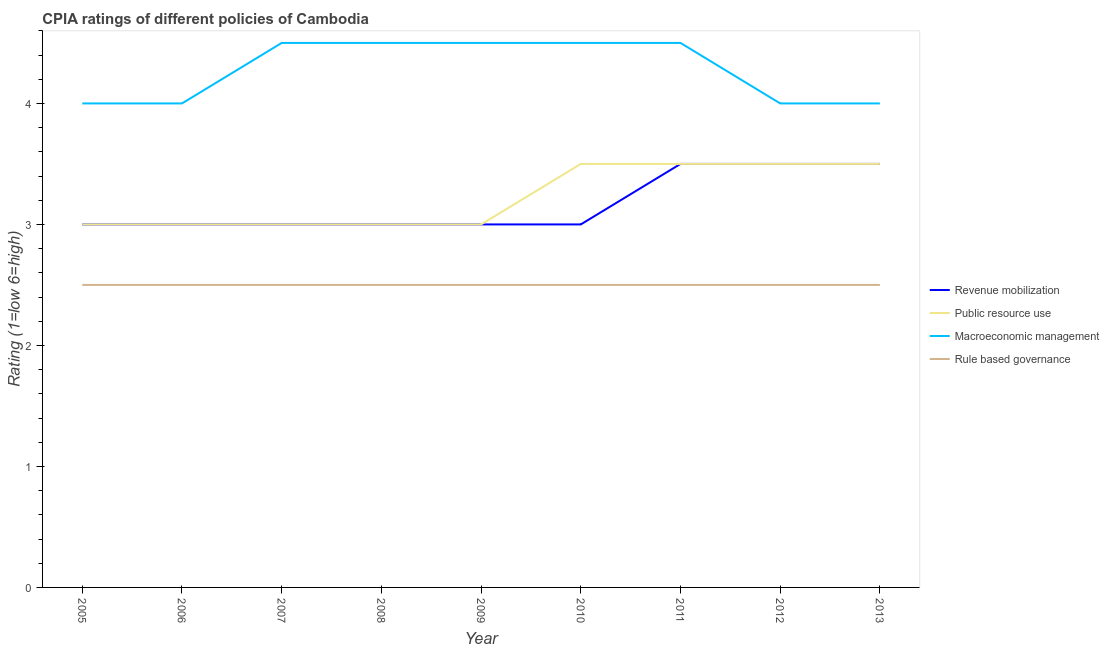How many different coloured lines are there?
Provide a short and direct response. 4. Does the line corresponding to cpia rating of public resource use intersect with the line corresponding to cpia rating of macroeconomic management?
Your response must be concise. No. Is the number of lines equal to the number of legend labels?
Your response must be concise. Yes. What is the cpia rating of public resource use in 2010?
Offer a very short reply. 3.5. Across all years, what is the maximum cpia rating of public resource use?
Keep it short and to the point. 3.5. Across all years, what is the minimum cpia rating of rule based governance?
Keep it short and to the point. 2.5. In which year was the cpia rating of revenue mobilization maximum?
Provide a short and direct response. 2011. In which year was the cpia rating of revenue mobilization minimum?
Your answer should be compact. 2005. What is the total cpia rating of rule based governance in the graph?
Your answer should be compact. 22.5. What is the average cpia rating of macroeconomic management per year?
Your response must be concise. 4.28. In how many years, is the cpia rating of revenue mobilization greater than 4.4?
Ensure brevity in your answer.  0. Is the difference between the cpia rating of public resource use in 2005 and 2008 greater than the difference between the cpia rating of macroeconomic management in 2005 and 2008?
Make the answer very short. Yes. What is the difference between the highest and the lowest cpia rating of revenue mobilization?
Your response must be concise. 0.5. Is it the case that in every year, the sum of the cpia rating of revenue mobilization and cpia rating of public resource use is greater than the sum of cpia rating of macroeconomic management and cpia rating of rule based governance?
Make the answer very short. No. Is it the case that in every year, the sum of the cpia rating of revenue mobilization and cpia rating of public resource use is greater than the cpia rating of macroeconomic management?
Your answer should be compact. Yes. Does the cpia rating of rule based governance monotonically increase over the years?
Your answer should be very brief. No. Is the cpia rating of public resource use strictly greater than the cpia rating of revenue mobilization over the years?
Ensure brevity in your answer.  No. Is the cpia rating of public resource use strictly less than the cpia rating of macroeconomic management over the years?
Provide a succinct answer. Yes. How many lines are there?
Your answer should be compact. 4. How many years are there in the graph?
Your answer should be very brief. 9. What is the difference between two consecutive major ticks on the Y-axis?
Offer a very short reply. 1. Are the values on the major ticks of Y-axis written in scientific E-notation?
Make the answer very short. No. Does the graph contain any zero values?
Keep it short and to the point. No. Where does the legend appear in the graph?
Your response must be concise. Center right. What is the title of the graph?
Offer a terse response. CPIA ratings of different policies of Cambodia. What is the label or title of the X-axis?
Offer a very short reply. Year. What is the label or title of the Y-axis?
Your answer should be very brief. Rating (1=low 6=high). What is the Rating (1=low 6=high) in Revenue mobilization in 2005?
Provide a succinct answer. 3. What is the Rating (1=low 6=high) of Public resource use in 2005?
Your answer should be very brief. 3. What is the Rating (1=low 6=high) in Macroeconomic management in 2005?
Give a very brief answer. 4. What is the Rating (1=low 6=high) in Revenue mobilization in 2006?
Offer a very short reply. 3. What is the Rating (1=low 6=high) in Macroeconomic management in 2006?
Keep it short and to the point. 4. What is the Rating (1=low 6=high) of Public resource use in 2007?
Your answer should be very brief. 3. What is the Rating (1=low 6=high) in Macroeconomic management in 2007?
Offer a very short reply. 4.5. What is the Rating (1=low 6=high) in Rule based governance in 2008?
Ensure brevity in your answer.  2.5. What is the Rating (1=low 6=high) of Public resource use in 2010?
Your answer should be compact. 3.5. What is the Rating (1=low 6=high) in Macroeconomic management in 2010?
Keep it short and to the point. 4.5. What is the Rating (1=low 6=high) of Rule based governance in 2010?
Ensure brevity in your answer.  2.5. What is the Rating (1=low 6=high) in Revenue mobilization in 2011?
Provide a succinct answer. 3.5. What is the Rating (1=low 6=high) in Rule based governance in 2011?
Keep it short and to the point. 2.5. What is the Rating (1=low 6=high) in Revenue mobilization in 2012?
Your answer should be compact. 3.5. What is the Rating (1=low 6=high) in Macroeconomic management in 2012?
Offer a terse response. 4. What is the Rating (1=low 6=high) of Rule based governance in 2012?
Offer a terse response. 2.5. What is the Rating (1=low 6=high) in Public resource use in 2013?
Offer a very short reply. 3.5. What is the Rating (1=low 6=high) of Macroeconomic management in 2013?
Your response must be concise. 4. Across all years, what is the maximum Rating (1=low 6=high) in Revenue mobilization?
Ensure brevity in your answer.  3.5. Across all years, what is the maximum Rating (1=low 6=high) in Macroeconomic management?
Offer a terse response. 4.5. Across all years, what is the maximum Rating (1=low 6=high) of Rule based governance?
Keep it short and to the point. 2.5. Across all years, what is the minimum Rating (1=low 6=high) in Revenue mobilization?
Keep it short and to the point. 3. Across all years, what is the minimum Rating (1=low 6=high) of Rule based governance?
Provide a short and direct response. 2.5. What is the total Rating (1=low 6=high) in Public resource use in the graph?
Offer a very short reply. 29. What is the total Rating (1=low 6=high) of Macroeconomic management in the graph?
Keep it short and to the point. 38.5. What is the total Rating (1=low 6=high) of Rule based governance in the graph?
Provide a short and direct response. 22.5. What is the difference between the Rating (1=low 6=high) in Public resource use in 2005 and that in 2006?
Make the answer very short. 0. What is the difference between the Rating (1=low 6=high) in Rule based governance in 2005 and that in 2006?
Make the answer very short. 0. What is the difference between the Rating (1=low 6=high) of Macroeconomic management in 2005 and that in 2007?
Your answer should be very brief. -0.5. What is the difference between the Rating (1=low 6=high) in Public resource use in 2005 and that in 2008?
Provide a succinct answer. 0. What is the difference between the Rating (1=low 6=high) of Rule based governance in 2005 and that in 2008?
Your response must be concise. 0. What is the difference between the Rating (1=low 6=high) of Revenue mobilization in 2005 and that in 2009?
Ensure brevity in your answer.  0. What is the difference between the Rating (1=low 6=high) of Public resource use in 2005 and that in 2009?
Make the answer very short. 0. What is the difference between the Rating (1=low 6=high) of Macroeconomic management in 2005 and that in 2009?
Ensure brevity in your answer.  -0.5. What is the difference between the Rating (1=low 6=high) in Revenue mobilization in 2005 and that in 2010?
Your answer should be compact. 0. What is the difference between the Rating (1=low 6=high) of Public resource use in 2005 and that in 2010?
Your answer should be very brief. -0.5. What is the difference between the Rating (1=low 6=high) of Revenue mobilization in 2005 and that in 2011?
Provide a succinct answer. -0.5. What is the difference between the Rating (1=low 6=high) of Macroeconomic management in 2005 and that in 2011?
Make the answer very short. -0.5. What is the difference between the Rating (1=low 6=high) of Revenue mobilization in 2005 and that in 2012?
Provide a succinct answer. -0.5. What is the difference between the Rating (1=low 6=high) in Macroeconomic management in 2005 and that in 2012?
Your answer should be compact. 0. What is the difference between the Rating (1=low 6=high) in Rule based governance in 2005 and that in 2012?
Keep it short and to the point. 0. What is the difference between the Rating (1=low 6=high) in Rule based governance in 2005 and that in 2013?
Your answer should be compact. 0. What is the difference between the Rating (1=low 6=high) of Revenue mobilization in 2006 and that in 2007?
Offer a very short reply. 0. What is the difference between the Rating (1=low 6=high) of Rule based governance in 2006 and that in 2007?
Offer a terse response. 0. What is the difference between the Rating (1=low 6=high) in Public resource use in 2006 and that in 2008?
Give a very brief answer. 0. What is the difference between the Rating (1=low 6=high) of Revenue mobilization in 2006 and that in 2009?
Your answer should be very brief. 0. What is the difference between the Rating (1=low 6=high) in Public resource use in 2006 and that in 2009?
Give a very brief answer. 0. What is the difference between the Rating (1=low 6=high) of Macroeconomic management in 2006 and that in 2009?
Keep it short and to the point. -0.5. What is the difference between the Rating (1=low 6=high) in Rule based governance in 2006 and that in 2009?
Provide a succinct answer. 0. What is the difference between the Rating (1=low 6=high) in Revenue mobilization in 2006 and that in 2010?
Your response must be concise. 0. What is the difference between the Rating (1=low 6=high) in Public resource use in 2006 and that in 2010?
Your answer should be very brief. -0.5. What is the difference between the Rating (1=low 6=high) in Revenue mobilization in 2006 and that in 2011?
Provide a succinct answer. -0.5. What is the difference between the Rating (1=low 6=high) in Rule based governance in 2006 and that in 2011?
Ensure brevity in your answer.  0. What is the difference between the Rating (1=low 6=high) of Revenue mobilization in 2006 and that in 2012?
Offer a terse response. -0.5. What is the difference between the Rating (1=low 6=high) of Public resource use in 2006 and that in 2012?
Your answer should be compact. -0.5. What is the difference between the Rating (1=low 6=high) in Rule based governance in 2006 and that in 2012?
Provide a short and direct response. 0. What is the difference between the Rating (1=low 6=high) in Macroeconomic management in 2006 and that in 2013?
Your answer should be very brief. 0. What is the difference between the Rating (1=low 6=high) in Rule based governance in 2006 and that in 2013?
Give a very brief answer. 0. What is the difference between the Rating (1=low 6=high) of Public resource use in 2007 and that in 2008?
Offer a terse response. 0. What is the difference between the Rating (1=low 6=high) of Rule based governance in 2007 and that in 2008?
Give a very brief answer. 0. What is the difference between the Rating (1=low 6=high) in Public resource use in 2007 and that in 2009?
Your response must be concise. 0. What is the difference between the Rating (1=low 6=high) of Rule based governance in 2007 and that in 2009?
Keep it short and to the point. 0. What is the difference between the Rating (1=low 6=high) in Revenue mobilization in 2007 and that in 2010?
Provide a short and direct response. 0. What is the difference between the Rating (1=low 6=high) of Public resource use in 2007 and that in 2010?
Your answer should be compact. -0.5. What is the difference between the Rating (1=low 6=high) of Macroeconomic management in 2007 and that in 2010?
Offer a very short reply. 0. What is the difference between the Rating (1=low 6=high) in Public resource use in 2007 and that in 2011?
Ensure brevity in your answer.  -0.5. What is the difference between the Rating (1=low 6=high) of Macroeconomic management in 2007 and that in 2011?
Provide a succinct answer. 0. What is the difference between the Rating (1=low 6=high) in Rule based governance in 2007 and that in 2011?
Give a very brief answer. 0. What is the difference between the Rating (1=low 6=high) of Macroeconomic management in 2007 and that in 2012?
Your answer should be compact. 0.5. What is the difference between the Rating (1=low 6=high) in Rule based governance in 2007 and that in 2012?
Your response must be concise. 0. What is the difference between the Rating (1=low 6=high) in Revenue mobilization in 2008 and that in 2009?
Provide a succinct answer. 0. What is the difference between the Rating (1=low 6=high) in Public resource use in 2008 and that in 2009?
Offer a terse response. 0. What is the difference between the Rating (1=low 6=high) in Rule based governance in 2008 and that in 2009?
Your response must be concise. 0. What is the difference between the Rating (1=low 6=high) in Revenue mobilization in 2008 and that in 2010?
Make the answer very short. 0. What is the difference between the Rating (1=low 6=high) of Macroeconomic management in 2008 and that in 2010?
Provide a short and direct response. 0. What is the difference between the Rating (1=low 6=high) in Macroeconomic management in 2008 and that in 2012?
Your answer should be very brief. 0.5. What is the difference between the Rating (1=low 6=high) in Public resource use in 2008 and that in 2013?
Provide a succinct answer. -0.5. What is the difference between the Rating (1=low 6=high) in Macroeconomic management in 2008 and that in 2013?
Provide a short and direct response. 0.5. What is the difference between the Rating (1=low 6=high) of Revenue mobilization in 2009 and that in 2010?
Your answer should be very brief. 0. What is the difference between the Rating (1=low 6=high) of Rule based governance in 2009 and that in 2010?
Your answer should be compact. 0. What is the difference between the Rating (1=low 6=high) of Macroeconomic management in 2009 and that in 2011?
Provide a short and direct response. 0. What is the difference between the Rating (1=low 6=high) in Rule based governance in 2009 and that in 2011?
Provide a succinct answer. 0. What is the difference between the Rating (1=low 6=high) of Public resource use in 2009 and that in 2012?
Your response must be concise. -0.5. What is the difference between the Rating (1=low 6=high) in Macroeconomic management in 2009 and that in 2012?
Ensure brevity in your answer.  0.5. What is the difference between the Rating (1=low 6=high) of Revenue mobilization in 2009 and that in 2013?
Provide a succinct answer. -0.5. What is the difference between the Rating (1=low 6=high) in Public resource use in 2009 and that in 2013?
Keep it short and to the point. -0.5. What is the difference between the Rating (1=low 6=high) of Revenue mobilization in 2010 and that in 2011?
Your answer should be compact. -0.5. What is the difference between the Rating (1=low 6=high) in Macroeconomic management in 2010 and that in 2011?
Keep it short and to the point. 0. What is the difference between the Rating (1=low 6=high) of Rule based governance in 2010 and that in 2011?
Keep it short and to the point. 0. What is the difference between the Rating (1=low 6=high) in Macroeconomic management in 2010 and that in 2012?
Offer a terse response. 0.5. What is the difference between the Rating (1=low 6=high) in Rule based governance in 2010 and that in 2012?
Make the answer very short. 0. What is the difference between the Rating (1=low 6=high) in Revenue mobilization in 2010 and that in 2013?
Provide a short and direct response. -0.5. What is the difference between the Rating (1=low 6=high) in Macroeconomic management in 2010 and that in 2013?
Keep it short and to the point. 0.5. What is the difference between the Rating (1=low 6=high) in Rule based governance in 2010 and that in 2013?
Your answer should be very brief. 0. What is the difference between the Rating (1=low 6=high) of Revenue mobilization in 2011 and that in 2012?
Provide a succinct answer. 0. What is the difference between the Rating (1=low 6=high) in Public resource use in 2011 and that in 2013?
Give a very brief answer. 0. What is the difference between the Rating (1=low 6=high) in Macroeconomic management in 2011 and that in 2013?
Your response must be concise. 0.5. What is the difference between the Rating (1=low 6=high) of Public resource use in 2012 and that in 2013?
Your answer should be compact. 0. What is the difference between the Rating (1=low 6=high) in Macroeconomic management in 2012 and that in 2013?
Offer a very short reply. 0. What is the difference between the Rating (1=low 6=high) in Rule based governance in 2012 and that in 2013?
Your answer should be compact. 0. What is the difference between the Rating (1=low 6=high) in Revenue mobilization in 2005 and the Rating (1=low 6=high) in Macroeconomic management in 2006?
Your answer should be very brief. -1. What is the difference between the Rating (1=low 6=high) of Revenue mobilization in 2005 and the Rating (1=low 6=high) of Rule based governance in 2006?
Provide a succinct answer. 0.5. What is the difference between the Rating (1=low 6=high) of Public resource use in 2005 and the Rating (1=low 6=high) of Macroeconomic management in 2006?
Provide a succinct answer. -1. What is the difference between the Rating (1=low 6=high) of Macroeconomic management in 2005 and the Rating (1=low 6=high) of Rule based governance in 2006?
Keep it short and to the point. 1.5. What is the difference between the Rating (1=low 6=high) of Revenue mobilization in 2005 and the Rating (1=low 6=high) of Public resource use in 2007?
Your answer should be very brief. 0. What is the difference between the Rating (1=low 6=high) of Revenue mobilization in 2005 and the Rating (1=low 6=high) of Macroeconomic management in 2007?
Keep it short and to the point. -1.5. What is the difference between the Rating (1=low 6=high) of Revenue mobilization in 2005 and the Rating (1=low 6=high) of Rule based governance in 2007?
Make the answer very short. 0.5. What is the difference between the Rating (1=low 6=high) in Public resource use in 2005 and the Rating (1=low 6=high) in Macroeconomic management in 2007?
Provide a short and direct response. -1.5. What is the difference between the Rating (1=low 6=high) of Macroeconomic management in 2005 and the Rating (1=low 6=high) of Rule based governance in 2007?
Offer a very short reply. 1.5. What is the difference between the Rating (1=low 6=high) of Revenue mobilization in 2005 and the Rating (1=low 6=high) of Public resource use in 2008?
Keep it short and to the point. 0. What is the difference between the Rating (1=low 6=high) of Revenue mobilization in 2005 and the Rating (1=low 6=high) of Rule based governance in 2008?
Offer a terse response. 0.5. What is the difference between the Rating (1=low 6=high) of Public resource use in 2005 and the Rating (1=low 6=high) of Rule based governance in 2008?
Your answer should be compact. 0.5. What is the difference between the Rating (1=low 6=high) in Revenue mobilization in 2005 and the Rating (1=low 6=high) in Macroeconomic management in 2009?
Keep it short and to the point. -1.5. What is the difference between the Rating (1=low 6=high) in Public resource use in 2005 and the Rating (1=low 6=high) in Rule based governance in 2009?
Give a very brief answer. 0.5. What is the difference between the Rating (1=low 6=high) of Revenue mobilization in 2005 and the Rating (1=low 6=high) of Public resource use in 2010?
Your answer should be compact. -0.5. What is the difference between the Rating (1=low 6=high) of Revenue mobilization in 2005 and the Rating (1=low 6=high) of Macroeconomic management in 2010?
Keep it short and to the point. -1.5. What is the difference between the Rating (1=low 6=high) of Macroeconomic management in 2005 and the Rating (1=low 6=high) of Rule based governance in 2010?
Make the answer very short. 1.5. What is the difference between the Rating (1=low 6=high) of Revenue mobilization in 2005 and the Rating (1=low 6=high) of Public resource use in 2011?
Provide a succinct answer. -0.5. What is the difference between the Rating (1=low 6=high) in Revenue mobilization in 2005 and the Rating (1=low 6=high) in Macroeconomic management in 2011?
Offer a terse response. -1.5. What is the difference between the Rating (1=low 6=high) in Revenue mobilization in 2005 and the Rating (1=low 6=high) in Public resource use in 2012?
Make the answer very short. -0.5. What is the difference between the Rating (1=low 6=high) of Revenue mobilization in 2005 and the Rating (1=low 6=high) of Macroeconomic management in 2012?
Ensure brevity in your answer.  -1. What is the difference between the Rating (1=low 6=high) in Public resource use in 2005 and the Rating (1=low 6=high) in Macroeconomic management in 2012?
Offer a terse response. -1. What is the difference between the Rating (1=low 6=high) of Public resource use in 2005 and the Rating (1=low 6=high) of Rule based governance in 2012?
Offer a terse response. 0.5. What is the difference between the Rating (1=low 6=high) of Macroeconomic management in 2005 and the Rating (1=low 6=high) of Rule based governance in 2012?
Give a very brief answer. 1.5. What is the difference between the Rating (1=low 6=high) of Revenue mobilization in 2005 and the Rating (1=low 6=high) of Rule based governance in 2013?
Keep it short and to the point. 0.5. What is the difference between the Rating (1=low 6=high) in Public resource use in 2005 and the Rating (1=low 6=high) in Rule based governance in 2013?
Give a very brief answer. 0.5. What is the difference between the Rating (1=low 6=high) in Public resource use in 2006 and the Rating (1=low 6=high) in Macroeconomic management in 2007?
Offer a terse response. -1.5. What is the difference between the Rating (1=low 6=high) in Macroeconomic management in 2006 and the Rating (1=low 6=high) in Rule based governance in 2007?
Offer a very short reply. 1.5. What is the difference between the Rating (1=low 6=high) of Revenue mobilization in 2006 and the Rating (1=low 6=high) of Rule based governance in 2008?
Your response must be concise. 0.5. What is the difference between the Rating (1=low 6=high) of Public resource use in 2006 and the Rating (1=low 6=high) of Macroeconomic management in 2008?
Give a very brief answer. -1.5. What is the difference between the Rating (1=low 6=high) of Public resource use in 2006 and the Rating (1=low 6=high) of Rule based governance in 2008?
Your answer should be very brief. 0.5. What is the difference between the Rating (1=low 6=high) in Macroeconomic management in 2006 and the Rating (1=low 6=high) in Rule based governance in 2008?
Provide a succinct answer. 1.5. What is the difference between the Rating (1=low 6=high) of Revenue mobilization in 2006 and the Rating (1=low 6=high) of Public resource use in 2009?
Keep it short and to the point. 0. What is the difference between the Rating (1=low 6=high) of Revenue mobilization in 2006 and the Rating (1=low 6=high) of Macroeconomic management in 2009?
Your answer should be very brief. -1.5. What is the difference between the Rating (1=low 6=high) in Revenue mobilization in 2006 and the Rating (1=low 6=high) in Rule based governance in 2009?
Your response must be concise. 0.5. What is the difference between the Rating (1=low 6=high) in Public resource use in 2006 and the Rating (1=low 6=high) in Rule based governance in 2009?
Provide a succinct answer. 0.5. What is the difference between the Rating (1=low 6=high) of Revenue mobilization in 2006 and the Rating (1=low 6=high) of Public resource use in 2010?
Your answer should be very brief. -0.5. What is the difference between the Rating (1=low 6=high) of Revenue mobilization in 2006 and the Rating (1=low 6=high) of Macroeconomic management in 2010?
Provide a short and direct response. -1.5. What is the difference between the Rating (1=low 6=high) of Revenue mobilization in 2006 and the Rating (1=low 6=high) of Rule based governance in 2010?
Provide a short and direct response. 0.5. What is the difference between the Rating (1=low 6=high) of Public resource use in 2006 and the Rating (1=low 6=high) of Macroeconomic management in 2010?
Your answer should be compact. -1.5. What is the difference between the Rating (1=low 6=high) of Public resource use in 2006 and the Rating (1=low 6=high) of Rule based governance in 2010?
Offer a very short reply. 0.5. What is the difference between the Rating (1=low 6=high) of Macroeconomic management in 2006 and the Rating (1=low 6=high) of Rule based governance in 2010?
Provide a succinct answer. 1.5. What is the difference between the Rating (1=low 6=high) of Revenue mobilization in 2006 and the Rating (1=low 6=high) of Public resource use in 2011?
Give a very brief answer. -0.5. What is the difference between the Rating (1=low 6=high) in Revenue mobilization in 2006 and the Rating (1=low 6=high) in Rule based governance in 2011?
Your answer should be very brief. 0.5. What is the difference between the Rating (1=low 6=high) in Public resource use in 2006 and the Rating (1=low 6=high) in Macroeconomic management in 2011?
Offer a terse response. -1.5. What is the difference between the Rating (1=low 6=high) in Public resource use in 2006 and the Rating (1=low 6=high) in Rule based governance in 2011?
Keep it short and to the point. 0.5. What is the difference between the Rating (1=low 6=high) of Macroeconomic management in 2006 and the Rating (1=low 6=high) of Rule based governance in 2011?
Provide a succinct answer. 1.5. What is the difference between the Rating (1=low 6=high) of Revenue mobilization in 2006 and the Rating (1=low 6=high) of Public resource use in 2012?
Provide a succinct answer. -0.5. What is the difference between the Rating (1=low 6=high) of Revenue mobilization in 2006 and the Rating (1=low 6=high) of Macroeconomic management in 2012?
Ensure brevity in your answer.  -1. What is the difference between the Rating (1=low 6=high) of Revenue mobilization in 2006 and the Rating (1=low 6=high) of Rule based governance in 2012?
Your answer should be very brief. 0.5. What is the difference between the Rating (1=low 6=high) of Public resource use in 2006 and the Rating (1=low 6=high) of Macroeconomic management in 2012?
Offer a terse response. -1. What is the difference between the Rating (1=low 6=high) of Public resource use in 2006 and the Rating (1=low 6=high) of Macroeconomic management in 2013?
Offer a very short reply. -1. What is the difference between the Rating (1=low 6=high) of Public resource use in 2006 and the Rating (1=low 6=high) of Rule based governance in 2013?
Your answer should be compact. 0.5. What is the difference between the Rating (1=low 6=high) of Revenue mobilization in 2007 and the Rating (1=low 6=high) of Macroeconomic management in 2008?
Your answer should be compact. -1.5. What is the difference between the Rating (1=low 6=high) in Public resource use in 2007 and the Rating (1=low 6=high) in Rule based governance in 2008?
Your response must be concise. 0.5. What is the difference between the Rating (1=low 6=high) in Revenue mobilization in 2007 and the Rating (1=low 6=high) in Rule based governance in 2009?
Make the answer very short. 0.5. What is the difference between the Rating (1=low 6=high) in Public resource use in 2007 and the Rating (1=low 6=high) in Rule based governance in 2009?
Provide a succinct answer. 0.5. What is the difference between the Rating (1=low 6=high) of Revenue mobilization in 2007 and the Rating (1=low 6=high) of Rule based governance in 2010?
Offer a very short reply. 0.5. What is the difference between the Rating (1=low 6=high) of Public resource use in 2007 and the Rating (1=low 6=high) of Macroeconomic management in 2010?
Your answer should be very brief. -1.5. What is the difference between the Rating (1=low 6=high) of Public resource use in 2007 and the Rating (1=low 6=high) of Rule based governance in 2010?
Provide a short and direct response. 0.5. What is the difference between the Rating (1=low 6=high) of Macroeconomic management in 2007 and the Rating (1=low 6=high) of Rule based governance in 2010?
Keep it short and to the point. 2. What is the difference between the Rating (1=low 6=high) of Revenue mobilization in 2007 and the Rating (1=low 6=high) of Rule based governance in 2011?
Offer a terse response. 0.5. What is the difference between the Rating (1=low 6=high) in Public resource use in 2007 and the Rating (1=low 6=high) in Macroeconomic management in 2011?
Give a very brief answer. -1.5. What is the difference between the Rating (1=low 6=high) in Revenue mobilization in 2007 and the Rating (1=low 6=high) in Macroeconomic management in 2012?
Offer a very short reply. -1. What is the difference between the Rating (1=low 6=high) in Public resource use in 2007 and the Rating (1=low 6=high) in Rule based governance in 2012?
Ensure brevity in your answer.  0.5. What is the difference between the Rating (1=low 6=high) of Macroeconomic management in 2007 and the Rating (1=low 6=high) of Rule based governance in 2012?
Make the answer very short. 2. What is the difference between the Rating (1=low 6=high) of Revenue mobilization in 2007 and the Rating (1=low 6=high) of Macroeconomic management in 2013?
Offer a terse response. -1. What is the difference between the Rating (1=low 6=high) of Revenue mobilization in 2007 and the Rating (1=low 6=high) of Rule based governance in 2013?
Provide a succinct answer. 0.5. What is the difference between the Rating (1=low 6=high) in Public resource use in 2007 and the Rating (1=low 6=high) in Macroeconomic management in 2013?
Keep it short and to the point. -1. What is the difference between the Rating (1=low 6=high) of Revenue mobilization in 2008 and the Rating (1=low 6=high) of Macroeconomic management in 2009?
Ensure brevity in your answer.  -1.5. What is the difference between the Rating (1=low 6=high) of Revenue mobilization in 2008 and the Rating (1=low 6=high) of Rule based governance in 2009?
Your answer should be compact. 0.5. What is the difference between the Rating (1=low 6=high) of Public resource use in 2008 and the Rating (1=low 6=high) of Rule based governance in 2009?
Your answer should be very brief. 0.5. What is the difference between the Rating (1=low 6=high) of Revenue mobilization in 2008 and the Rating (1=low 6=high) of Public resource use in 2011?
Your response must be concise. -0.5. What is the difference between the Rating (1=low 6=high) of Revenue mobilization in 2008 and the Rating (1=low 6=high) of Macroeconomic management in 2011?
Offer a very short reply. -1.5. What is the difference between the Rating (1=low 6=high) of Revenue mobilization in 2008 and the Rating (1=low 6=high) of Rule based governance in 2011?
Give a very brief answer. 0.5. What is the difference between the Rating (1=low 6=high) of Public resource use in 2008 and the Rating (1=low 6=high) of Macroeconomic management in 2011?
Your response must be concise. -1.5. What is the difference between the Rating (1=low 6=high) in Macroeconomic management in 2008 and the Rating (1=low 6=high) in Rule based governance in 2011?
Your response must be concise. 2. What is the difference between the Rating (1=low 6=high) of Revenue mobilization in 2008 and the Rating (1=low 6=high) of Rule based governance in 2012?
Your response must be concise. 0.5. What is the difference between the Rating (1=low 6=high) in Public resource use in 2008 and the Rating (1=low 6=high) in Macroeconomic management in 2012?
Your response must be concise. -1. What is the difference between the Rating (1=low 6=high) of Revenue mobilization in 2008 and the Rating (1=low 6=high) of Public resource use in 2013?
Provide a succinct answer. -0.5. What is the difference between the Rating (1=low 6=high) in Revenue mobilization in 2008 and the Rating (1=low 6=high) in Macroeconomic management in 2013?
Make the answer very short. -1. What is the difference between the Rating (1=low 6=high) in Public resource use in 2008 and the Rating (1=low 6=high) in Macroeconomic management in 2013?
Keep it short and to the point. -1. What is the difference between the Rating (1=low 6=high) in Public resource use in 2008 and the Rating (1=low 6=high) in Rule based governance in 2013?
Your answer should be compact. 0.5. What is the difference between the Rating (1=low 6=high) in Revenue mobilization in 2009 and the Rating (1=low 6=high) in Macroeconomic management in 2010?
Ensure brevity in your answer.  -1.5. What is the difference between the Rating (1=low 6=high) of Revenue mobilization in 2009 and the Rating (1=low 6=high) of Rule based governance in 2010?
Make the answer very short. 0.5. What is the difference between the Rating (1=low 6=high) of Public resource use in 2009 and the Rating (1=low 6=high) of Macroeconomic management in 2010?
Your answer should be compact. -1.5. What is the difference between the Rating (1=low 6=high) in Public resource use in 2009 and the Rating (1=low 6=high) in Rule based governance in 2010?
Your answer should be compact. 0.5. What is the difference between the Rating (1=low 6=high) of Macroeconomic management in 2009 and the Rating (1=low 6=high) of Rule based governance in 2010?
Offer a very short reply. 2. What is the difference between the Rating (1=low 6=high) in Revenue mobilization in 2009 and the Rating (1=low 6=high) in Macroeconomic management in 2011?
Your response must be concise. -1.5. What is the difference between the Rating (1=low 6=high) in Public resource use in 2009 and the Rating (1=low 6=high) in Macroeconomic management in 2011?
Provide a short and direct response. -1.5. What is the difference between the Rating (1=low 6=high) in Public resource use in 2009 and the Rating (1=low 6=high) in Rule based governance in 2011?
Your response must be concise. 0.5. What is the difference between the Rating (1=low 6=high) in Macroeconomic management in 2009 and the Rating (1=low 6=high) in Rule based governance in 2011?
Ensure brevity in your answer.  2. What is the difference between the Rating (1=low 6=high) in Revenue mobilization in 2009 and the Rating (1=low 6=high) in Public resource use in 2012?
Give a very brief answer. -0.5. What is the difference between the Rating (1=low 6=high) of Revenue mobilization in 2009 and the Rating (1=low 6=high) of Macroeconomic management in 2012?
Keep it short and to the point. -1. What is the difference between the Rating (1=low 6=high) of Revenue mobilization in 2009 and the Rating (1=low 6=high) of Rule based governance in 2012?
Provide a short and direct response. 0.5. What is the difference between the Rating (1=low 6=high) of Public resource use in 2009 and the Rating (1=low 6=high) of Macroeconomic management in 2012?
Make the answer very short. -1. What is the difference between the Rating (1=low 6=high) in Public resource use in 2009 and the Rating (1=low 6=high) in Rule based governance in 2012?
Make the answer very short. 0.5. What is the difference between the Rating (1=low 6=high) of Revenue mobilization in 2009 and the Rating (1=low 6=high) of Public resource use in 2013?
Provide a short and direct response. -0.5. What is the difference between the Rating (1=low 6=high) in Revenue mobilization in 2010 and the Rating (1=low 6=high) in Public resource use in 2011?
Provide a succinct answer. -0.5. What is the difference between the Rating (1=low 6=high) in Public resource use in 2010 and the Rating (1=low 6=high) in Macroeconomic management in 2011?
Offer a terse response. -1. What is the difference between the Rating (1=low 6=high) in Public resource use in 2010 and the Rating (1=low 6=high) in Rule based governance in 2011?
Keep it short and to the point. 1. What is the difference between the Rating (1=low 6=high) in Macroeconomic management in 2010 and the Rating (1=low 6=high) in Rule based governance in 2011?
Your answer should be very brief. 2. What is the difference between the Rating (1=low 6=high) of Revenue mobilization in 2010 and the Rating (1=low 6=high) of Public resource use in 2012?
Give a very brief answer. -0.5. What is the difference between the Rating (1=low 6=high) of Revenue mobilization in 2010 and the Rating (1=low 6=high) of Macroeconomic management in 2012?
Your answer should be compact. -1. What is the difference between the Rating (1=low 6=high) of Revenue mobilization in 2010 and the Rating (1=low 6=high) of Rule based governance in 2012?
Offer a terse response. 0.5. What is the difference between the Rating (1=low 6=high) of Macroeconomic management in 2010 and the Rating (1=low 6=high) of Rule based governance in 2012?
Offer a terse response. 2. What is the difference between the Rating (1=low 6=high) in Public resource use in 2010 and the Rating (1=low 6=high) in Macroeconomic management in 2013?
Ensure brevity in your answer.  -0.5. What is the difference between the Rating (1=low 6=high) of Revenue mobilization in 2011 and the Rating (1=low 6=high) of Macroeconomic management in 2012?
Provide a short and direct response. -0.5. What is the difference between the Rating (1=low 6=high) in Revenue mobilization in 2011 and the Rating (1=low 6=high) in Rule based governance in 2012?
Offer a terse response. 1. What is the difference between the Rating (1=low 6=high) of Revenue mobilization in 2011 and the Rating (1=low 6=high) of Public resource use in 2013?
Your answer should be very brief. 0. What is the difference between the Rating (1=low 6=high) of Public resource use in 2011 and the Rating (1=low 6=high) of Macroeconomic management in 2013?
Provide a short and direct response. -0.5. What is the difference between the Rating (1=low 6=high) of Public resource use in 2011 and the Rating (1=low 6=high) of Rule based governance in 2013?
Your answer should be compact. 1. What is the difference between the Rating (1=low 6=high) in Revenue mobilization in 2012 and the Rating (1=low 6=high) in Public resource use in 2013?
Your response must be concise. 0. What is the difference between the Rating (1=low 6=high) in Revenue mobilization in 2012 and the Rating (1=low 6=high) in Macroeconomic management in 2013?
Make the answer very short. -0.5. What is the difference between the Rating (1=low 6=high) of Revenue mobilization in 2012 and the Rating (1=low 6=high) of Rule based governance in 2013?
Keep it short and to the point. 1. What is the difference between the Rating (1=low 6=high) in Public resource use in 2012 and the Rating (1=low 6=high) in Rule based governance in 2013?
Your answer should be very brief. 1. What is the difference between the Rating (1=low 6=high) in Macroeconomic management in 2012 and the Rating (1=low 6=high) in Rule based governance in 2013?
Give a very brief answer. 1.5. What is the average Rating (1=low 6=high) of Revenue mobilization per year?
Your answer should be very brief. 3.17. What is the average Rating (1=low 6=high) of Public resource use per year?
Offer a terse response. 3.22. What is the average Rating (1=low 6=high) in Macroeconomic management per year?
Offer a very short reply. 4.28. What is the average Rating (1=low 6=high) of Rule based governance per year?
Offer a very short reply. 2.5. In the year 2005, what is the difference between the Rating (1=low 6=high) in Revenue mobilization and Rating (1=low 6=high) in Public resource use?
Your response must be concise. 0. In the year 2005, what is the difference between the Rating (1=low 6=high) in Public resource use and Rating (1=low 6=high) in Rule based governance?
Offer a very short reply. 0.5. In the year 2005, what is the difference between the Rating (1=low 6=high) of Macroeconomic management and Rating (1=low 6=high) of Rule based governance?
Provide a short and direct response. 1.5. In the year 2006, what is the difference between the Rating (1=low 6=high) in Revenue mobilization and Rating (1=low 6=high) in Public resource use?
Give a very brief answer. 0. In the year 2006, what is the difference between the Rating (1=low 6=high) in Revenue mobilization and Rating (1=low 6=high) in Macroeconomic management?
Your answer should be compact. -1. In the year 2006, what is the difference between the Rating (1=low 6=high) in Revenue mobilization and Rating (1=low 6=high) in Rule based governance?
Provide a succinct answer. 0.5. In the year 2006, what is the difference between the Rating (1=low 6=high) in Public resource use and Rating (1=low 6=high) in Macroeconomic management?
Keep it short and to the point. -1. In the year 2006, what is the difference between the Rating (1=low 6=high) of Macroeconomic management and Rating (1=low 6=high) of Rule based governance?
Keep it short and to the point. 1.5. In the year 2007, what is the difference between the Rating (1=low 6=high) of Revenue mobilization and Rating (1=low 6=high) of Rule based governance?
Your answer should be compact. 0.5. In the year 2007, what is the difference between the Rating (1=low 6=high) of Public resource use and Rating (1=low 6=high) of Macroeconomic management?
Give a very brief answer. -1.5. In the year 2007, what is the difference between the Rating (1=low 6=high) of Public resource use and Rating (1=low 6=high) of Rule based governance?
Your response must be concise. 0.5. In the year 2008, what is the difference between the Rating (1=low 6=high) in Revenue mobilization and Rating (1=low 6=high) in Macroeconomic management?
Provide a succinct answer. -1.5. In the year 2008, what is the difference between the Rating (1=low 6=high) in Revenue mobilization and Rating (1=low 6=high) in Rule based governance?
Provide a short and direct response. 0.5. In the year 2008, what is the difference between the Rating (1=low 6=high) in Public resource use and Rating (1=low 6=high) in Macroeconomic management?
Your response must be concise. -1.5. In the year 2008, what is the difference between the Rating (1=low 6=high) in Macroeconomic management and Rating (1=low 6=high) in Rule based governance?
Provide a succinct answer. 2. In the year 2009, what is the difference between the Rating (1=low 6=high) in Revenue mobilization and Rating (1=low 6=high) in Public resource use?
Provide a succinct answer. 0. In the year 2009, what is the difference between the Rating (1=low 6=high) of Revenue mobilization and Rating (1=low 6=high) of Macroeconomic management?
Your response must be concise. -1.5. In the year 2009, what is the difference between the Rating (1=low 6=high) in Revenue mobilization and Rating (1=low 6=high) in Rule based governance?
Your response must be concise. 0.5. In the year 2009, what is the difference between the Rating (1=low 6=high) of Public resource use and Rating (1=low 6=high) of Rule based governance?
Make the answer very short. 0.5. In the year 2010, what is the difference between the Rating (1=low 6=high) in Revenue mobilization and Rating (1=low 6=high) in Public resource use?
Make the answer very short. -0.5. In the year 2010, what is the difference between the Rating (1=low 6=high) of Revenue mobilization and Rating (1=low 6=high) of Macroeconomic management?
Ensure brevity in your answer.  -1.5. In the year 2010, what is the difference between the Rating (1=low 6=high) in Revenue mobilization and Rating (1=low 6=high) in Rule based governance?
Provide a succinct answer. 0.5. In the year 2010, what is the difference between the Rating (1=low 6=high) in Macroeconomic management and Rating (1=low 6=high) in Rule based governance?
Ensure brevity in your answer.  2. In the year 2011, what is the difference between the Rating (1=low 6=high) in Revenue mobilization and Rating (1=low 6=high) in Rule based governance?
Ensure brevity in your answer.  1. In the year 2011, what is the difference between the Rating (1=low 6=high) in Public resource use and Rating (1=low 6=high) in Macroeconomic management?
Your answer should be compact. -1. In the year 2011, what is the difference between the Rating (1=low 6=high) in Macroeconomic management and Rating (1=low 6=high) in Rule based governance?
Provide a succinct answer. 2. In the year 2012, what is the difference between the Rating (1=low 6=high) of Revenue mobilization and Rating (1=low 6=high) of Public resource use?
Keep it short and to the point. 0. In the year 2012, what is the difference between the Rating (1=low 6=high) of Revenue mobilization and Rating (1=low 6=high) of Rule based governance?
Make the answer very short. 1. In the year 2012, what is the difference between the Rating (1=low 6=high) in Public resource use and Rating (1=low 6=high) in Rule based governance?
Make the answer very short. 1. In the year 2013, what is the difference between the Rating (1=low 6=high) of Public resource use and Rating (1=low 6=high) of Macroeconomic management?
Provide a short and direct response. -0.5. In the year 2013, what is the difference between the Rating (1=low 6=high) of Macroeconomic management and Rating (1=low 6=high) of Rule based governance?
Make the answer very short. 1.5. What is the ratio of the Rating (1=low 6=high) in Revenue mobilization in 2005 to that in 2006?
Provide a succinct answer. 1. What is the ratio of the Rating (1=low 6=high) in Macroeconomic management in 2005 to that in 2006?
Give a very brief answer. 1. What is the ratio of the Rating (1=low 6=high) of Rule based governance in 2005 to that in 2006?
Give a very brief answer. 1. What is the ratio of the Rating (1=low 6=high) of Revenue mobilization in 2005 to that in 2007?
Your answer should be compact. 1. What is the ratio of the Rating (1=low 6=high) of Public resource use in 2005 to that in 2007?
Ensure brevity in your answer.  1. What is the ratio of the Rating (1=low 6=high) in Macroeconomic management in 2005 to that in 2007?
Keep it short and to the point. 0.89. What is the ratio of the Rating (1=low 6=high) of Rule based governance in 2005 to that in 2007?
Provide a succinct answer. 1. What is the ratio of the Rating (1=low 6=high) in Revenue mobilization in 2005 to that in 2008?
Give a very brief answer. 1. What is the ratio of the Rating (1=low 6=high) in Macroeconomic management in 2005 to that in 2008?
Provide a short and direct response. 0.89. What is the ratio of the Rating (1=low 6=high) in Public resource use in 2005 to that in 2009?
Provide a succinct answer. 1. What is the ratio of the Rating (1=low 6=high) of Macroeconomic management in 2005 to that in 2009?
Provide a succinct answer. 0.89. What is the ratio of the Rating (1=low 6=high) in Rule based governance in 2005 to that in 2009?
Your answer should be very brief. 1. What is the ratio of the Rating (1=low 6=high) in Rule based governance in 2005 to that in 2010?
Your answer should be very brief. 1. What is the ratio of the Rating (1=low 6=high) in Revenue mobilization in 2005 to that in 2011?
Your answer should be compact. 0.86. What is the ratio of the Rating (1=low 6=high) in Public resource use in 2005 to that in 2011?
Your answer should be compact. 0.86. What is the ratio of the Rating (1=low 6=high) in Macroeconomic management in 2005 to that in 2011?
Ensure brevity in your answer.  0.89. What is the ratio of the Rating (1=low 6=high) in Rule based governance in 2005 to that in 2011?
Your response must be concise. 1. What is the ratio of the Rating (1=low 6=high) in Macroeconomic management in 2005 to that in 2012?
Your answer should be very brief. 1. What is the ratio of the Rating (1=low 6=high) in Rule based governance in 2005 to that in 2012?
Ensure brevity in your answer.  1. What is the ratio of the Rating (1=low 6=high) in Revenue mobilization in 2005 to that in 2013?
Your answer should be compact. 0.86. What is the ratio of the Rating (1=low 6=high) in Public resource use in 2005 to that in 2013?
Ensure brevity in your answer.  0.86. What is the ratio of the Rating (1=low 6=high) of Macroeconomic management in 2005 to that in 2013?
Offer a very short reply. 1. What is the ratio of the Rating (1=low 6=high) in Rule based governance in 2005 to that in 2013?
Make the answer very short. 1. What is the ratio of the Rating (1=low 6=high) in Revenue mobilization in 2006 to that in 2007?
Offer a terse response. 1. What is the ratio of the Rating (1=low 6=high) in Rule based governance in 2006 to that in 2007?
Ensure brevity in your answer.  1. What is the ratio of the Rating (1=low 6=high) in Revenue mobilization in 2006 to that in 2008?
Keep it short and to the point. 1. What is the ratio of the Rating (1=low 6=high) in Public resource use in 2006 to that in 2008?
Keep it short and to the point. 1. What is the ratio of the Rating (1=low 6=high) in Rule based governance in 2006 to that in 2008?
Give a very brief answer. 1. What is the ratio of the Rating (1=low 6=high) of Rule based governance in 2006 to that in 2009?
Your response must be concise. 1. What is the ratio of the Rating (1=low 6=high) of Revenue mobilization in 2006 to that in 2010?
Your answer should be compact. 1. What is the ratio of the Rating (1=low 6=high) in Public resource use in 2006 to that in 2010?
Give a very brief answer. 0.86. What is the ratio of the Rating (1=low 6=high) of Rule based governance in 2006 to that in 2010?
Offer a very short reply. 1. What is the ratio of the Rating (1=low 6=high) in Public resource use in 2006 to that in 2011?
Offer a very short reply. 0.86. What is the ratio of the Rating (1=low 6=high) in Rule based governance in 2006 to that in 2011?
Provide a succinct answer. 1. What is the ratio of the Rating (1=low 6=high) of Public resource use in 2006 to that in 2012?
Your answer should be compact. 0.86. What is the ratio of the Rating (1=low 6=high) in Macroeconomic management in 2006 to that in 2012?
Your response must be concise. 1. What is the ratio of the Rating (1=low 6=high) in Public resource use in 2006 to that in 2013?
Your answer should be very brief. 0.86. What is the ratio of the Rating (1=low 6=high) in Macroeconomic management in 2006 to that in 2013?
Offer a terse response. 1. What is the ratio of the Rating (1=low 6=high) of Rule based governance in 2006 to that in 2013?
Offer a terse response. 1. What is the ratio of the Rating (1=low 6=high) in Revenue mobilization in 2007 to that in 2008?
Give a very brief answer. 1. What is the ratio of the Rating (1=low 6=high) in Public resource use in 2007 to that in 2008?
Make the answer very short. 1. What is the ratio of the Rating (1=low 6=high) of Rule based governance in 2007 to that in 2008?
Offer a very short reply. 1. What is the ratio of the Rating (1=low 6=high) in Revenue mobilization in 2007 to that in 2009?
Make the answer very short. 1. What is the ratio of the Rating (1=low 6=high) in Revenue mobilization in 2007 to that in 2012?
Ensure brevity in your answer.  0.86. What is the ratio of the Rating (1=low 6=high) of Rule based governance in 2007 to that in 2012?
Offer a terse response. 1. What is the ratio of the Rating (1=low 6=high) in Revenue mobilization in 2008 to that in 2009?
Offer a terse response. 1. What is the ratio of the Rating (1=low 6=high) in Macroeconomic management in 2008 to that in 2009?
Provide a short and direct response. 1. What is the ratio of the Rating (1=low 6=high) in Rule based governance in 2008 to that in 2009?
Give a very brief answer. 1. What is the ratio of the Rating (1=low 6=high) of Rule based governance in 2008 to that in 2010?
Give a very brief answer. 1. What is the ratio of the Rating (1=low 6=high) of Revenue mobilization in 2008 to that in 2011?
Your answer should be compact. 0.86. What is the ratio of the Rating (1=low 6=high) of Revenue mobilization in 2008 to that in 2012?
Ensure brevity in your answer.  0.86. What is the ratio of the Rating (1=low 6=high) in Public resource use in 2008 to that in 2012?
Offer a terse response. 0.86. What is the ratio of the Rating (1=low 6=high) in Revenue mobilization in 2008 to that in 2013?
Provide a short and direct response. 0.86. What is the ratio of the Rating (1=low 6=high) of Public resource use in 2008 to that in 2013?
Your response must be concise. 0.86. What is the ratio of the Rating (1=low 6=high) of Rule based governance in 2008 to that in 2013?
Provide a short and direct response. 1. What is the ratio of the Rating (1=low 6=high) of Revenue mobilization in 2009 to that in 2010?
Ensure brevity in your answer.  1. What is the ratio of the Rating (1=low 6=high) of Macroeconomic management in 2009 to that in 2010?
Your answer should be very brief. 1. What is the ratio of the Rating (1=low 6=high) of Revenue mobilization in 2009 to that in 2011?
Offer a very short reply. 0.86. What is the ratio of the Rating (1=low 6=high) of Macroeconomic management in 2009 to that in 2011?
Provide a short and direct response. 1. What is the ratio of the Rating (1=low 6=high) in Revenue mobilization in 2009 to that in 2012?
Provide a short and direct response. 0.86. What is the ratio of the Rating (1=low 6=high) of Revenue mobilization in 2009 to that in 2013?
Your answer should be compact. 0.86. What is the ratio of the Rating (1=low 6=high) of Macroeconomic management in 2009 to that in 2013?
Provide a succinct answer. 1.12. What is the ratio of the Rating (1=low 6=high) of Revenue mobilization in 2010 to that in 2011?
Your answer should be very brief. 0.86. What is the ratio of the Rating (1=low 6=high) of Public resource use in 2010 to that in 2011?
Provide a short and direct response. 1. What is the ratio of the Rating (1=low 6=high) of Macroeconomic management in 2010 to that in 2011?
Your response must be concise. 1. What is the ratio of the Rating (1=low 6=high) of Rule based governance in 2010 to that in 2011?
Give a very brief answer. 1. What is the ratio of the Rating (1=low 6=high) of Revenue mobilization in 2010 to that in 2012?
Offer a terse response. 0.86. What is the ratio of the Rating (1=low 6=high) in Rule based governance in 2010 to that in 2012?
Give a very brief answer. 1. What is the ratio of the Rating (1=low 6=high) of Macroeconomic management in 2010 to that in 2013?
Keep it short and to the point. 1.12. What is the ratio of the Rating (1=low 6=high) in Revenue mobilization in 2011 to that in 2012?
Provide a succinct answer. 1. What is the ratio of the Rating (1=low 6=high) in Public resource use in 2011 to that in 2013?
Offer a very short reply. 1. What is the ratio of the Rating (1=low 6=high) of Macroeconomic management in 2012 to that in 2013?
Your response must be concise. 1. What is the ratio of the Rating (1=low 6=high) in Rule based governance in 2012 to that in 2013?
Your answer should be compact. 1. What is the difference between the highest and the second highest Rating (1=low 6=high) in Revenue mobilization?
Offer a very short reply. 0. What is the difference between the highest and the second highest Rating (1=low 6=high) in Rule based governance?
Your answer should be compact. 0. What is the difference between the highest and the lowest Rating (1=low 6=high) in Revenue mobilization?
Make the answer very short. 0.5. What is the difference between the highest and the lowest Rating (1=low 6=high) of Rule based governance?
Offer a terse response. 0. 